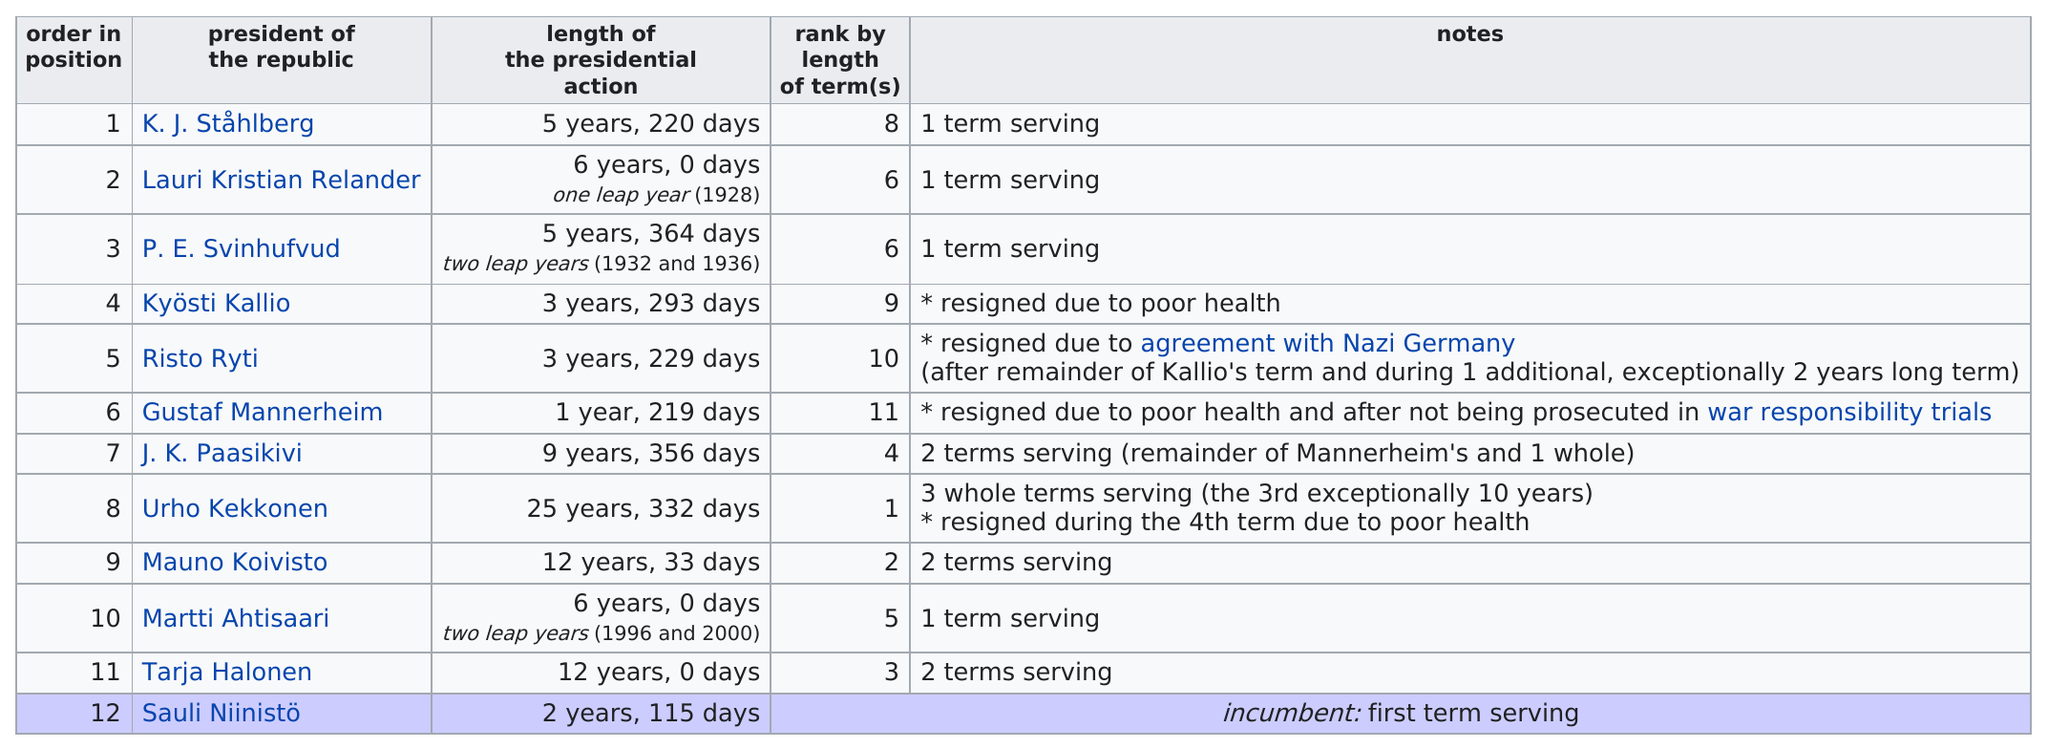Draw attention to some important aspects in this diagram. Each president of the republic who served for five years served a single term. Risto Ryti, the president of the republic, served a three-year term but did not resign due to poor health. Urho Kekkonen is the person who served the most terms in office. Mauno Koivisto served more terms in office than Martti Ahtisaari. Risto Ryti served a term before Mannerheim, who was the previous president of Finland. 